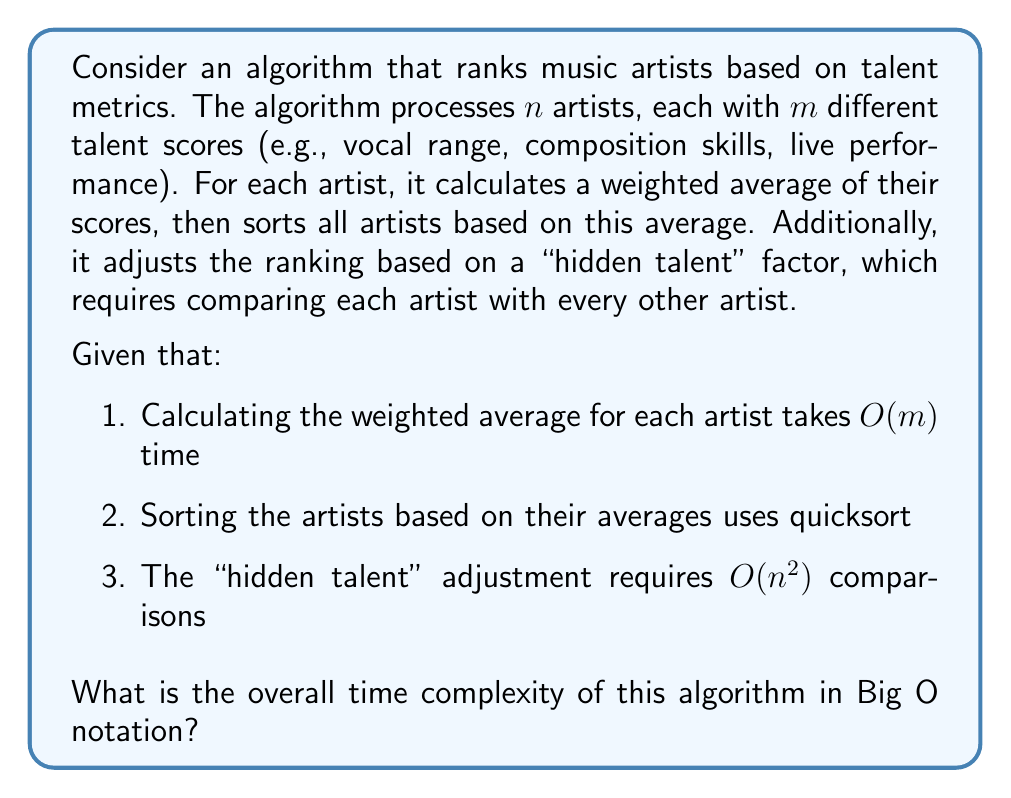Could you help me with this problem? Let's break down the algorithm and analyze each step:

1. Calculating weighted averages:
   - For each of the $n$ artists, we perform $m$ operations
   - Time complexity: $O(n \cdot m)$

2. Sorting artists based on averages:
   - Using quicksort, which has an average-case time complexity of $O(n \log n)$
   - Time complexity: $O(n \log n)$

3. "Hidden talent" adjustment:
   - Comparing each artist with every other artist
   - Time complexity: $O(n^2)$

To determine the overall time complexity, we need to sum these components:

$$T(n, m) = O(n \cdot m) + O(n \log n) + O(n^2)$$

Now, we need to simplify this expression:

1. $O(n \cdot m)$ can be considered $O(n)$ if $m$ is constant, but we'll keep it as is since $m$ might vary
2. $O(n \log n)$ is always smaller than $O(n^2)$, so it can be absorbed into $O(n^2)$
3. $O(n \cdot m)$ is smaller than $O(n^2)$ for large $n$, unless $m > n$

Therefore, the simplified time complexity is:

$$T(n, m) = O(\max(n \cdot m, n^2))$$

This means the algorithm's time complexity is dominated by either the weighted average calculation or the "hidden talent" adjustment, whichever is larger.
Answer: $O(\max(n \cdot m, n^2))$ 